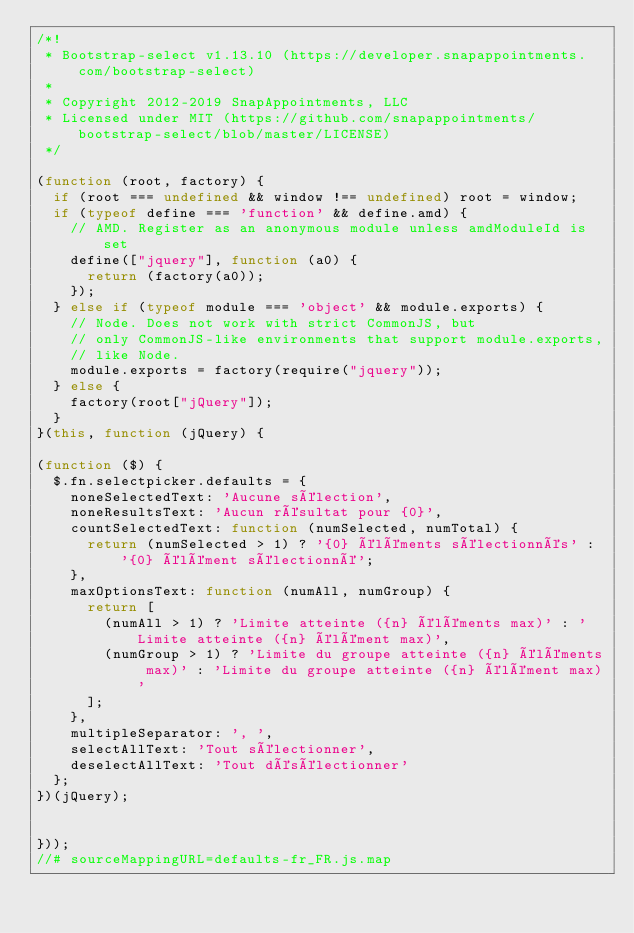Convert code to text. <code><loc_0><loc_0><loc_500><loc_500><_JavaScript_>/*!
 * Bootstrap-select v1.13.10 (https://developer.snapappointments.com/bootstrap-select)
 *
 * Copyright 2012-2019 SnapAppointments, LLC
 * Licensed under MIT (https://github.com/snapappointments/bootstrap-select/blob/master/LICENSE)
 */

(function (root, factory) {
  if (root === undefined && window !== undefined) root = window;
  if (typeof define === 'function' && define.amd) {
    // AMD. Register as an anonymous module unless amdModuleId is set
    define(["jquery"], function (a0) {
      return (factory(a0));
    });
  } else if (typeof module === 'object' && module.exports) {
    // Node. Does not work with strict CommonJS, but
    // only CommonJS-like environments that support module.exports,
    // like Node.
    module.exports = factory(require("jquery"));
  } else {
    factory(root["jQuery"]);
  }
}(this, function (jQuery) {

(function ($) {
  $.fn.selectpicker.defaults = {
    noneSelectedText: 'Aucune sélection',
    noneResultsText: 'Aucun résultat pour {0}',
    countSelectedText: function (numSelected, numTotal) {
      return (numSelected > 1) ? '{0} éléments sélectionnés' : '{0} élément sélectionné';
    },
    maxOptionsText: function (numAll, numGroup) {
      return [
        (numAll > 1) ? 'Limite atteinte ({n} éléments max)' : 'Limite atteinte ({n} élément max)',
        (numGroup > 1) ? 'Limite du groupe atteinte ({n} éléments max)' : 'Limite du groupe atteinte ({n} élément max)'
      ];
    },
    multipleSeparator: ', ',
    selectAllText: 'Tout sélectionner',
    deselectAllText: 'Tout désélectionner'
  };
})(jQuery);


}));
//# sourceMappingURL=defaults-fr_FR.js.map</code> 